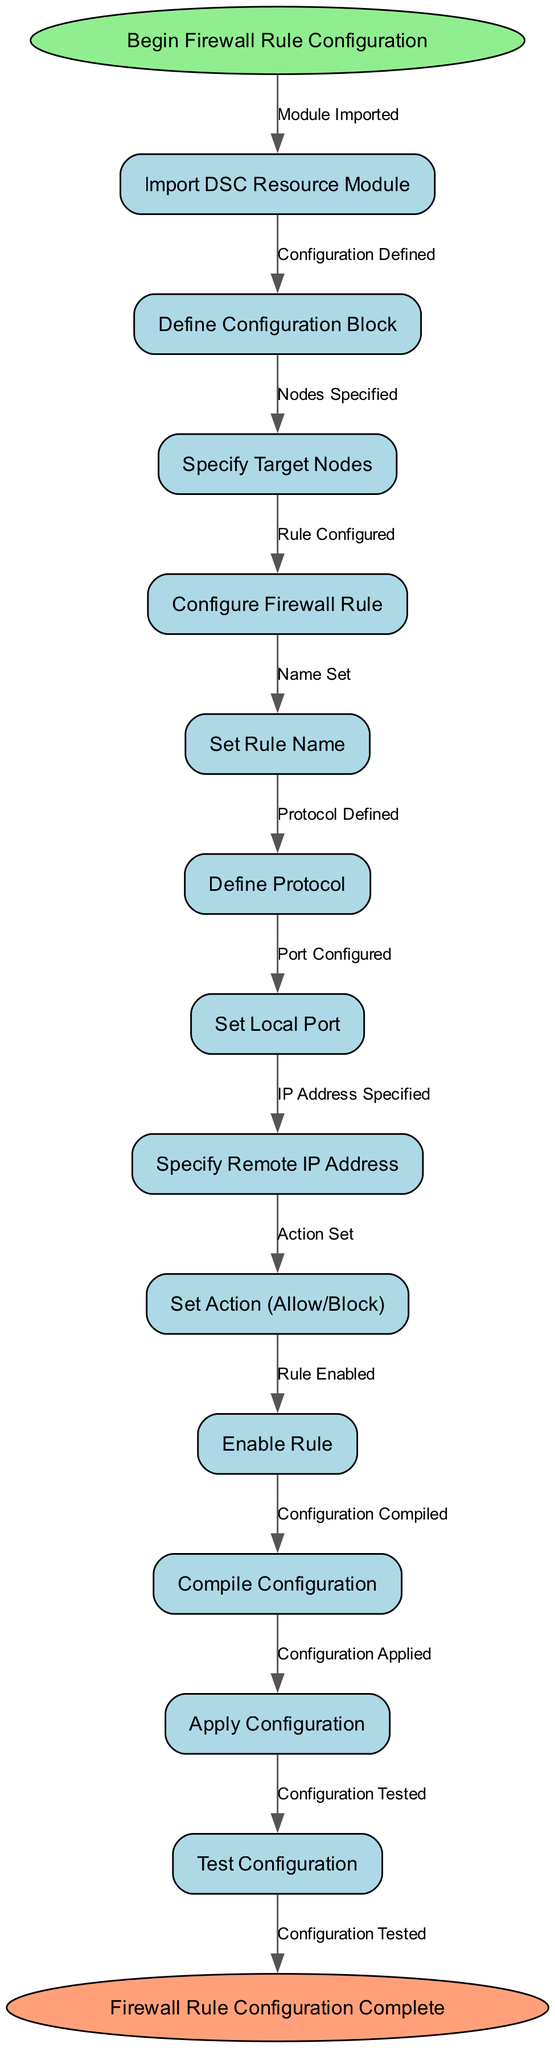What is the starting point of the diagram? The starting point of the diagram is labeled "Begin Firewall Rule Configuration". This is the first node indicated at the top of the flow, setting the context for the process that follows.
Answer: Begin Firewall Rule Configuration How many nodes are present in the diagram? The diagram contains a total of 13 nodes, which includes the start and end nodes, as well as the functional steps in the configuration process.
Answer: 13 What is the last step before reaching the end of the diagram? The last step before reaching the end node is "Configuration Tested". This is the final action taken in the process before completing the firewall rule configuration, linking it to the end node.
Answer: Configuration Tested Which node directly follows "Enable Rule"? The node that directly follows "Enable Rule" is "Compile Configuration". This indicates the next logical step in the process after enabling the firewall rule.
Answer: Compile Configuration What is the relationship between "Define Protocol" and "Specify Remote IP Address"? "Define Protocol" comes before "Specify Remote IP Address", suggesting that the protocol must be defined before specifying any remote addresses related to the firewall rule configuration. This indicates a sequential dependency in the flowchart.
Answer: Sequential dependency How many edges are defined in the diagram? There are 12 edges defined in the diagram, representing the connections or transitions between each of the nodes throughout the process.
Answer: 12 What is the action taken after "Specify Target Nodes"? The action taken after "Specify Target Nodes" is "Configure Firewall Rule". This step follows the specification of which nodes are targeted as part of the processing flow.
Answer: Configure Firewall Rule What type of node is used for the start and end points in the diagram? In this diagram, the start and end points are represented as elliptical nodes. This shape differentiates them from the other rectangular nodes used for the functional steps.
Answer: Elliptical nodes Which step involves setting the desired outcome for the firewall rule? The step that involves setting the desired outcome for the firewall rule is "Set Action (Allow/Block)". This action determines whether the traffic will be allowed or blocked through the configured firewall rule.
Answer: Set Action (Allow/Block) 